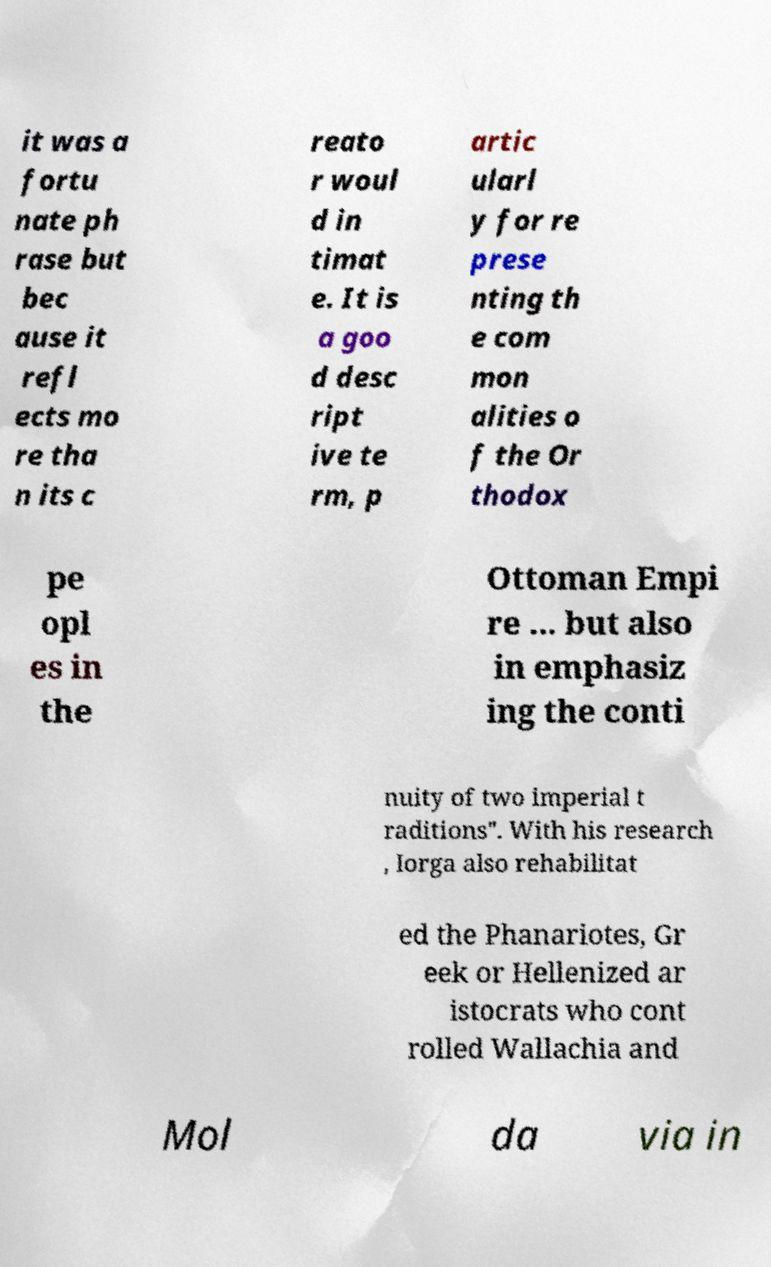What messages or text are displayed in this image? I need them in a readable, typed format. it was a fortu nate ph rase but bec ause it refl ects mo re tha n its c reato r woul d in timat e. It is a goo d desc ript ive te rm, p artic ularl y for re prese nting th e com mon alities o f the Or thodox pe opl es in the Ottoman Empi re ... but also in emphasiz ing the conti nuity of two imperial t raditions". With his research , Iorga also rehabilitat ed the Phanariotes, Gr eek or Hellenized ar istocrats who cont rolled Wallachia and Mol da via in 